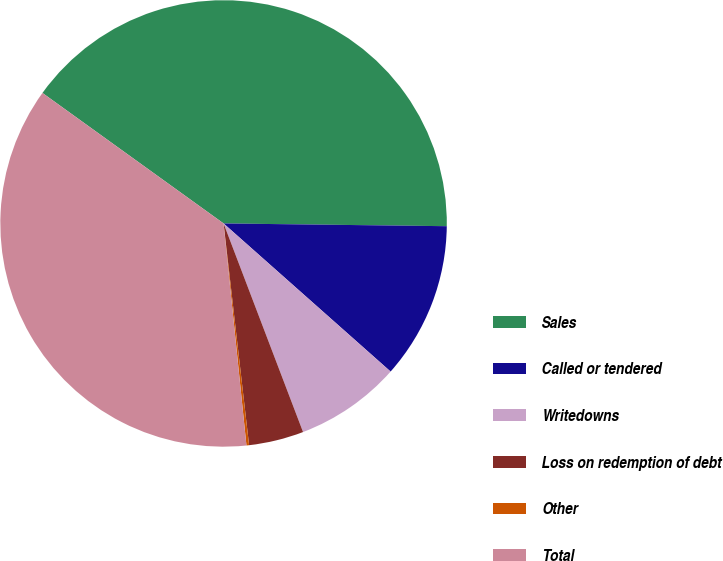Convert chart to OTSL. <chart><loc_0><loc_0><loc_500><loc_500><pie_chart><fcel>Sales<fcel>Called or tendered<fcel>Writedowns<fcel>Loss on redemption of debt<fcel>Other<fcel>Total<nl><fcel>40.26%<fcel>11.35%<fcel>7.66%<fcel>3.97%<fcel>0.19%<fcel>36.57%<nl></chart> 